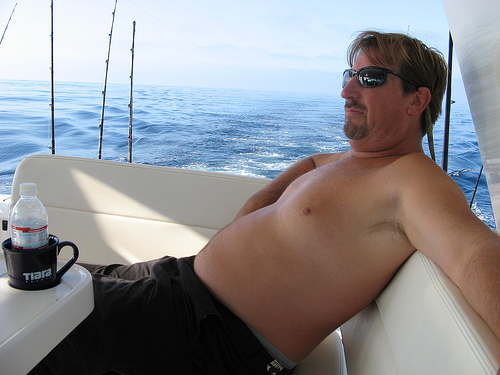<image>
Is there a cup in front of the man? Yes. The cup is positioned in front of the man, appearing closer to the camera viewpoint. 